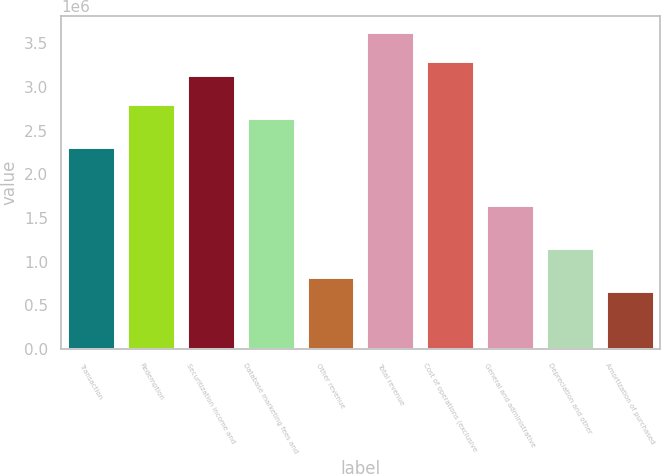Convert chart to OTSL. <chart><loc_0><loc_0><loc_500><loc_500><bar_chart><fcel>Transaction<fcel>Redemption<fcel>Securitization income and<fcel>Database marketing fees and<fcel>Other revenue<fcel>Total revenue<fcel>Cost of operations (exclusive<fcel>General and administrative<fcel>Depreciation and other<fcel>Amortization of purchased<nl><fcel>2.31077e+06<fcel>2.80593e+06<fcel>3.13604e+06<fcel>2.64088e+06<fcel>825275<fcel>3.63121e+06<fcel>3.3011e+06<fcel>1.65055e+06<fcel>1.15538e+06<fcel>660220<nl></chart> 